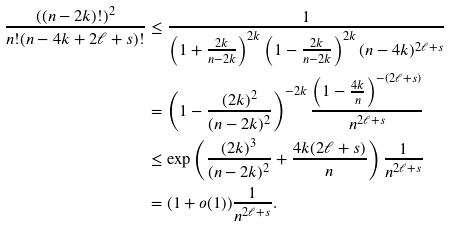Convert formula to latex. <formula><loc_0><loc_0><loc_500><loc_500>\frac { ( ( n - 2 k ) ! ) ^ { 2 } } { n ! ( n - 4 k + 2 \ell + s ) ! } & \leq \frac { 1 } { \left ( 1 + \frac { 2 k } { n - 2 k } \right ) ^ { 2 k } \left ( 1 - \frac { 2 k } { n - 2 k } \right ) ^ { 2 k } ( n - 4 k ) ^ { 2 \ell + s } } \\ & = \left ( 1 - \frac { ( 2 k ) ^ { 2 } } { ( n - 2 k ) ^ { 2 } } \right ) ^ { - 2 k } \frac { \left ( 1 - \frac { 4 k } { n } \right ) ^ { - ( 2 \ell + s ) } } { n ^ { 2 \ell + s } } \\ & \leq \exp \left ( \frac { ( 2 k ) ^ { 3 } } { ( n - 2 k ) ^ { 2 } } + \frac { 4 k ( 2 \ell + s ) } { n } \right ) \frac { 1 } { n ^ { 2 \ell + s } } \\ & = ( 1 + o ( 1 ) ) \frac { 1 } { n ^ { 2 \ell + s } } .</formula> 